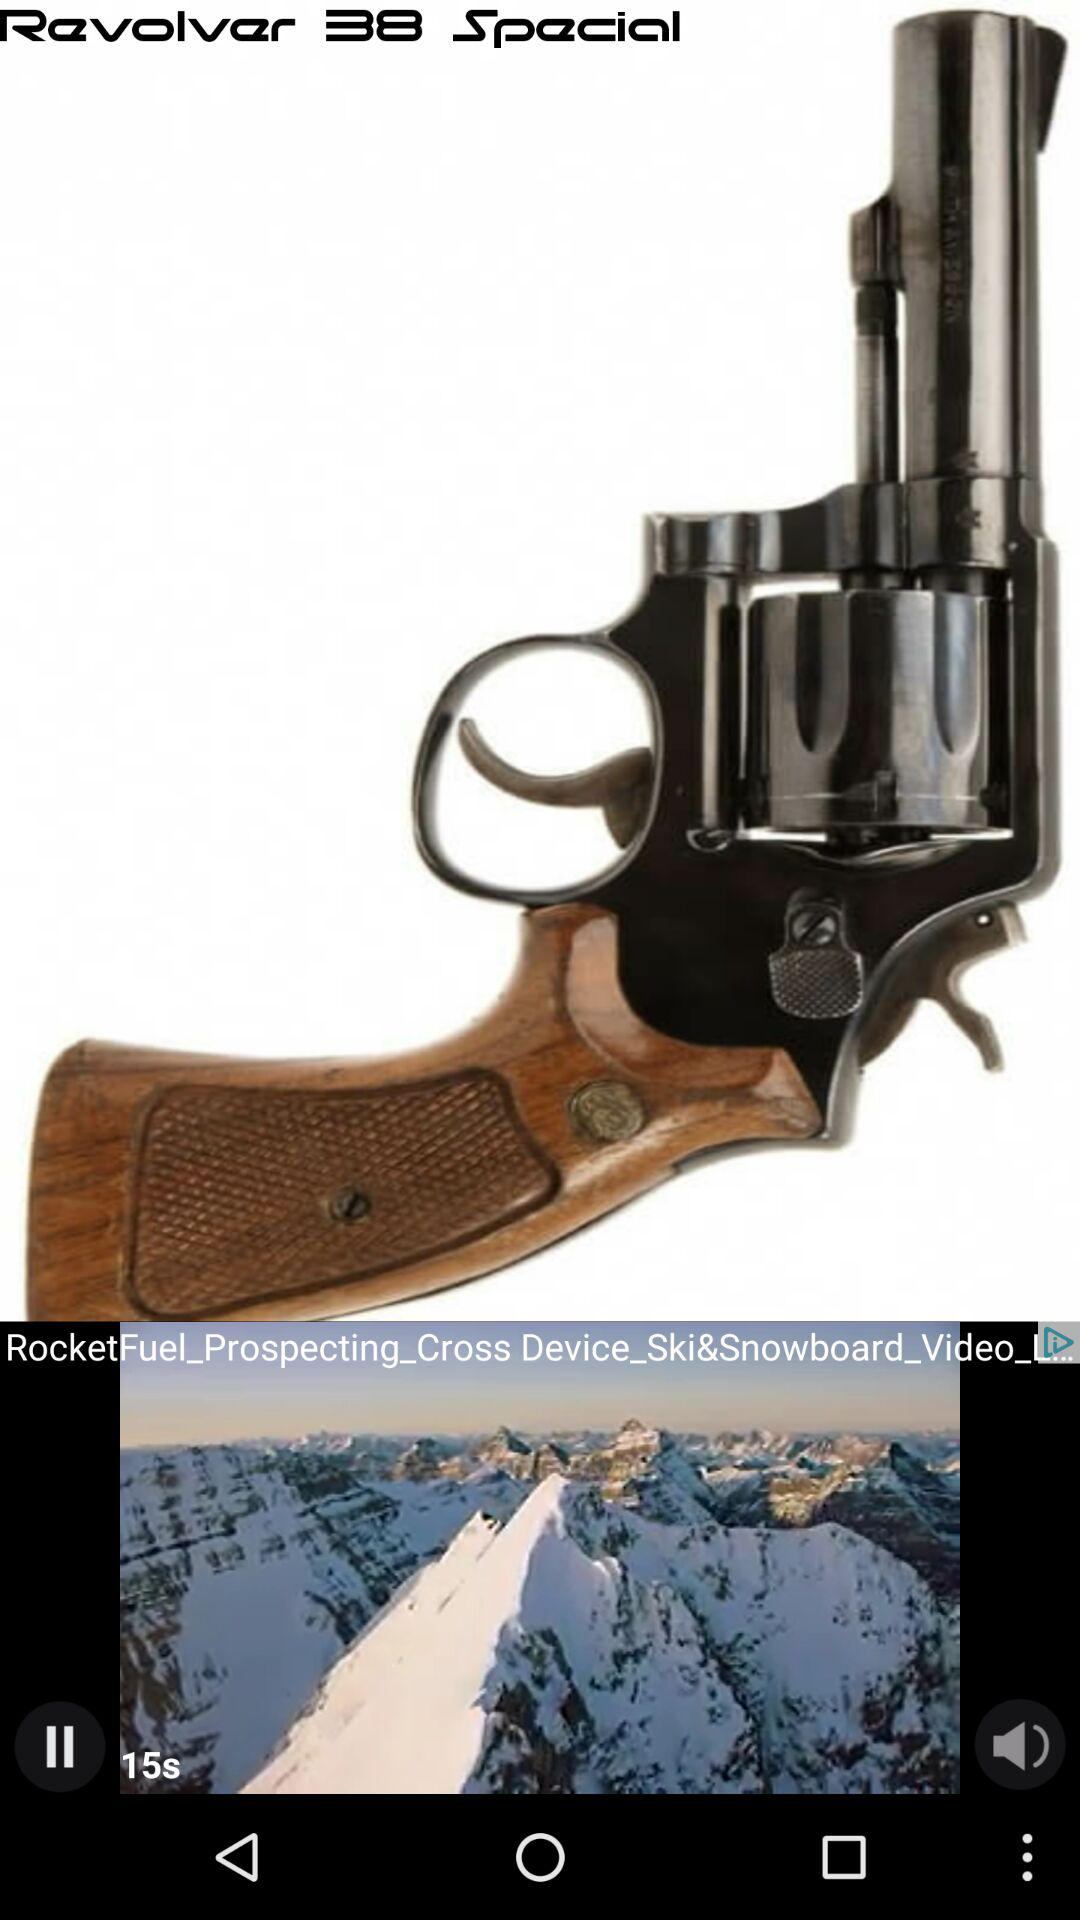Which video is playing? The playing video is "RocketFuel_Prospecting_Cross Device_Ski&Snowboard_Video_L...". 